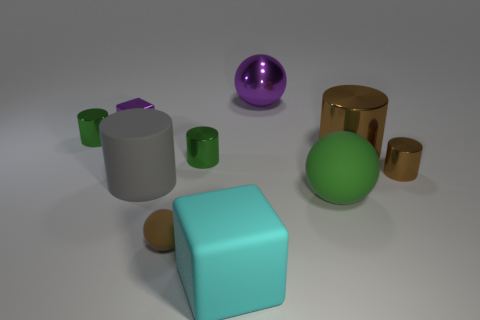How many brown cylinders must be subtracted to get 1 brown cylinders? 1 Subtract all tiny green shiny cylinders. How many cylinders are left? 3 Subtract 1 blocks. How many blocks are left? 1 Subtract all green cylinders. How many cylinders are left? 3 Subtract all brown cubes. How many gray cylinders are left? 1 Subtract all big rubber cylinders. Subtract all gray matte things. How many objects are left? 8 Add 9 big cyan things. How many big cyan things are left? 10 Add 9 green spheres. How many green spheres exist? 10 Subtract 0 yellow cylinders. How many objects are left? 10 Subtract all spheres. How many objects are left? 7 